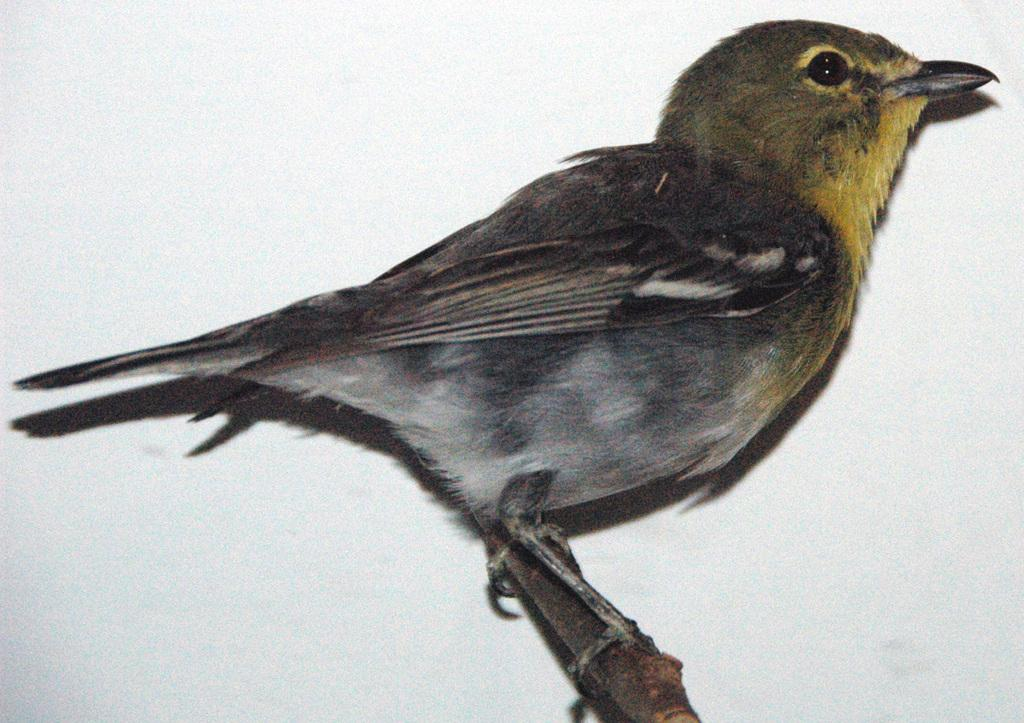What type of animal can be seen in the image? There is a bird in the image. Where is the bird located? The bird is standing on a branch. What color is the background of the image? The background of the image is white in color. What type of jam is the bird eating in the image? There is no jam present in the image; the bird is standing on a branch. How many sheep can be seen in the image? There are no sheep present in the image; it features a bird on a branch. 